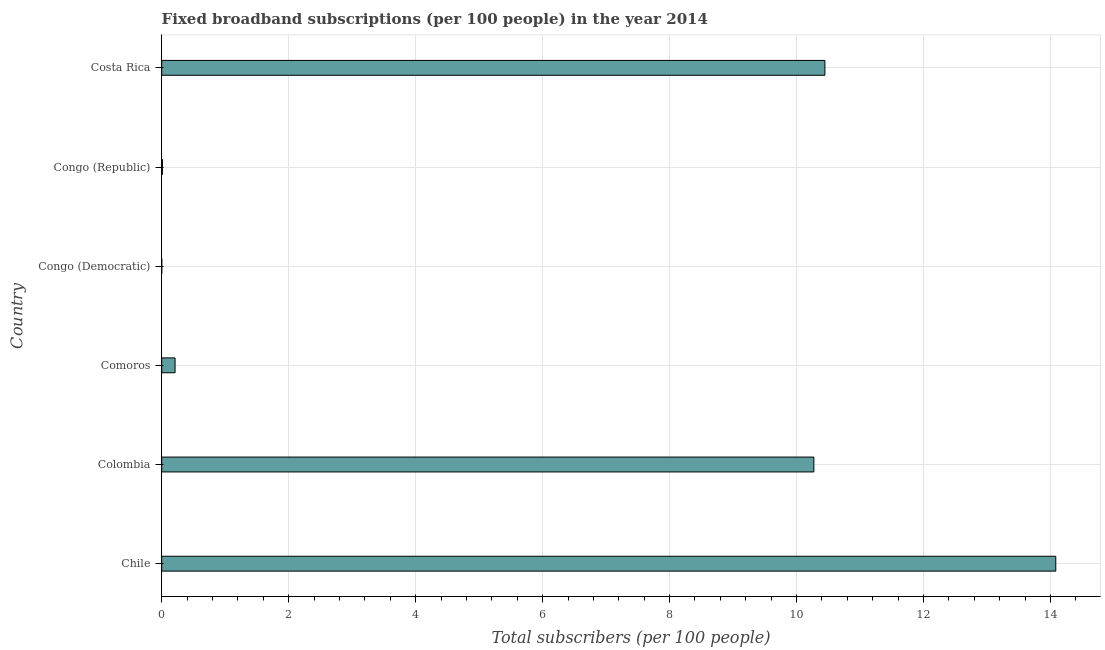What is the title of the graph?
Make the answer very short. Fixed broadband subscriptions (per 100 people) in the year 2014. What is the label or title of the X-axis?
Give a very brief answer. Total subscribers (per 100 people). What is the label or title of the Y-axis?
Provide a short and direct response. Country. What is the total number of fixed broadband subscriptions in Congo (Republic)?
Make the answer very short. 0.01. Across all countries, what is the maximum total number of fixed broadband subscriptions?
Provide a short and direct response. 14.08. Across all countries, what is the minimum total number of fixed broadband subscriptions?
Make the answer very short. 0. In which country was the total number of fixed broadband subscriptions maximum?
Ensure brevity in your answer.  Chile. In which country was the total number of fixed broadband subscriptions minimum?
Offer a terse response. Congo (Democratic). What is the sum of the total number of fixed broadband subscriptions?
Provide a short and direct response. 35.03. What is the difference between the total number of fixed broadband subscriptions in Chile and Congo (Democratic)?
Your answer should be compact. 14.08. What is the average total number of fixed broadband subscriptions per country?
Your answer should be compact. 5.84. What is the median total number of fixed broadband subscriptions?
Give a very brief answer. 5.24. What is the ratio of the total number of fixed broadband subscriptions in Comoros to that in Congo (Republic)?
Give a very brief answer. 19.18. What is the difference between the highest and the second highest total number of fixed broadband subscriptions?
Your answer should be very brief. 3.64. What is the difference between the highest and the lowest total number of fixed broadband subscriptions?
Give a very brief answer. 14.08. In how many countries, is the total number of fixed broadband subscriptions greater than the average total number of fixed broadband subscriptions taken over all countries?
Make the answer very short. 3. Are all the bars in the graph horizontal?
Offer a very short reply. Yes. What is the Total subscribers (per 100 people) of Chile?
Your response must be concise. 14.08. What is the Total subscribers (per 100 people) in Colombia?
Your answer should be very brief. 10.27. What is the Total subscribers (per 100 people) of Comoros?
Offer a terse response. 0.21. What is the Total subscribers (per 100 people) in Congo (Democratic)?
Provide a short and direct response. 0. What is the Total subscribers (per 100 people) in Congo (Republic)?
Give a very brief answer. 0.01. What is the Total subscribers (per 100 people) of Costa Rica?
Your answer should be very brief. 10.45. What is the difference between the Total subscribers (per 100 people) in Chile and Colombia?
Your answer should be very brief. 3.81. What is the difference between the Total subscribers (per 100 people) in Chile and Comoros?
Your answer should be very brief. 13.87. What is the difference between the Total subscribers (per 100 people) in Chile and Congo (Democratic)?
Make the answer very short. 14.08. What is the difference between the Total subscribers (per 100 people) in Chile and Congo (Republic)?
Make the answer very short. 14.07. What is the difference between the Total subscribers (per 100 people) in Chile and Costa Rica?
Offer a very short reply. 3.64. What is the difference between the Total subscribers (per 100 people) in Colombia and Comoros?
Provide a succinct answer. 10.06. What is the difference between the Total subscribers (per 100 people) in Colombia and Congo (Democratic)?
Offer a very short reply. 10.27. What is the difference between the Total subscribers (per 100 people) in Colombia and Congo (Republic)?
Provide a short and direct response. 10.26. What is the difference between the Total subscribers (per 100 people) in Colombia and Costa Rica?
Provide a short and direct response. -0.17. What is the difference between the Total subscribers (per 100 people) in Comoros and Congo (Democratic)?
Keep it short and to the point. 0.21. What is the difference between the Total subscribers (per 100 people) in Comoros and Congo (Republic)?
Your answer should be very brief. 0.2. What is the difference between the Total subscribers (per 100 people) in Comoros and Costa Rica?
Your response must be concise. -10.24. What is the difference between the Total subscribers (per 100 people) in Congo (Democratic) and Congo (Republic)?
Your answer should be very brief. -0.01. What is the difference between the Total subscribers (per 100 people) in Congo (Democratic) and Costa Rica?
Give a very brief answer. -10.45. What is the difference between the Total subscribers (per 100 people) in Congo (Republic) and Costa Rica?
Offer a very short reply. -10.44. What is the ratio of the Total subscribers (per 100 people) in Chile to that in Colombia?
Keep it short and to the point. 1.37. What is the ratio of the Total subscribers (per 100 people) in Chile to that in Comoros?
Offer a very short reply. 66.94. What is the ratio of the Total subscribers (per 100 people) in Chile to that in Congo (Democratic)?
Give a very brief answer. 1.95e+04. What is the ratio of the Total subscribers (per 100 people) in Chile to that in Congo (Republic)?
Your answer should be very brief. 1284.03. What is the ratio of the Total subscribers (per 100 people) in Chile to that in Costa Rica?
Offer a very short reply. 1.35. What is the ratio of the Total subscribers (per 100 people) in Colombia to that in Comoros?
Provide a short and direct response. 48.83. What is the ratio of the Total subscribers (per 100 people) in Colombia to that in Congo (Democratic)?
Give a very brief answer. 1.43e+04. What is the ratio of the Total subscribers (per 100 people) in Colombia to that in Congo (Republic)?
Make the answer very short. 936.59. What is the ratio of the Total subscribers (per 100 people) in Comoros to that in Congo (Democratic)?
Offer a terse response. 291.84. What is the ratio of the Total subscribers (per 100 people) in Comoros to that in Congo (Republic)?
Your answer should be compact. 19.18. What is the ratio of the Total subscribers (per 100 people) in Comoros to that in Costa Rica?
Provide a short and direct response. 0.02. What is the ratio of the Total subscribers (per 100 people) in Congo (Democratic) to that in Congo (Republic)?
Ensure brevity in your answer.  0.07. What is the ratio of the Total subscribers (per 100 people) in Congo (Republic) to that in Costa Rica?
Offer a very short reply. 0. 